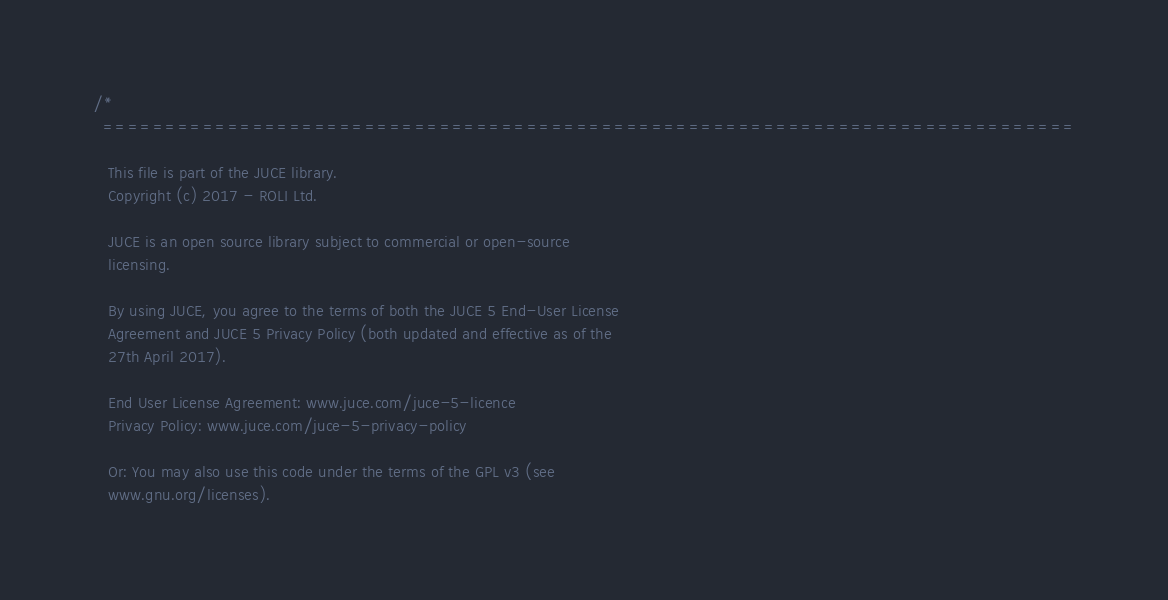<code> <loc_0><loc_0><loc_500><loc_500><_ObjectiveC_>/*
  ==============================================================================

   This file is part of the JUCE library.
   Copyright (c) 2017 - ROLI Ltd.

   JUCE is an open source library subject to commercial or open-source
   licensing.

   By using JUCE, you agree to the terms of both the JUCE 5 End-User License
   Agreement and JUCE 5 Privacy Policy (both updated and effective as of the
   27th April 2017).

   End User License Agreement: www.juce.com/juce-5-licence
   Privacy Policy: www.juce.com/juce-5-privacy-policy

   Or: You may also use this code under the terms of the GPL v3 (see
   www.gnu.org/licenses).
</code> 